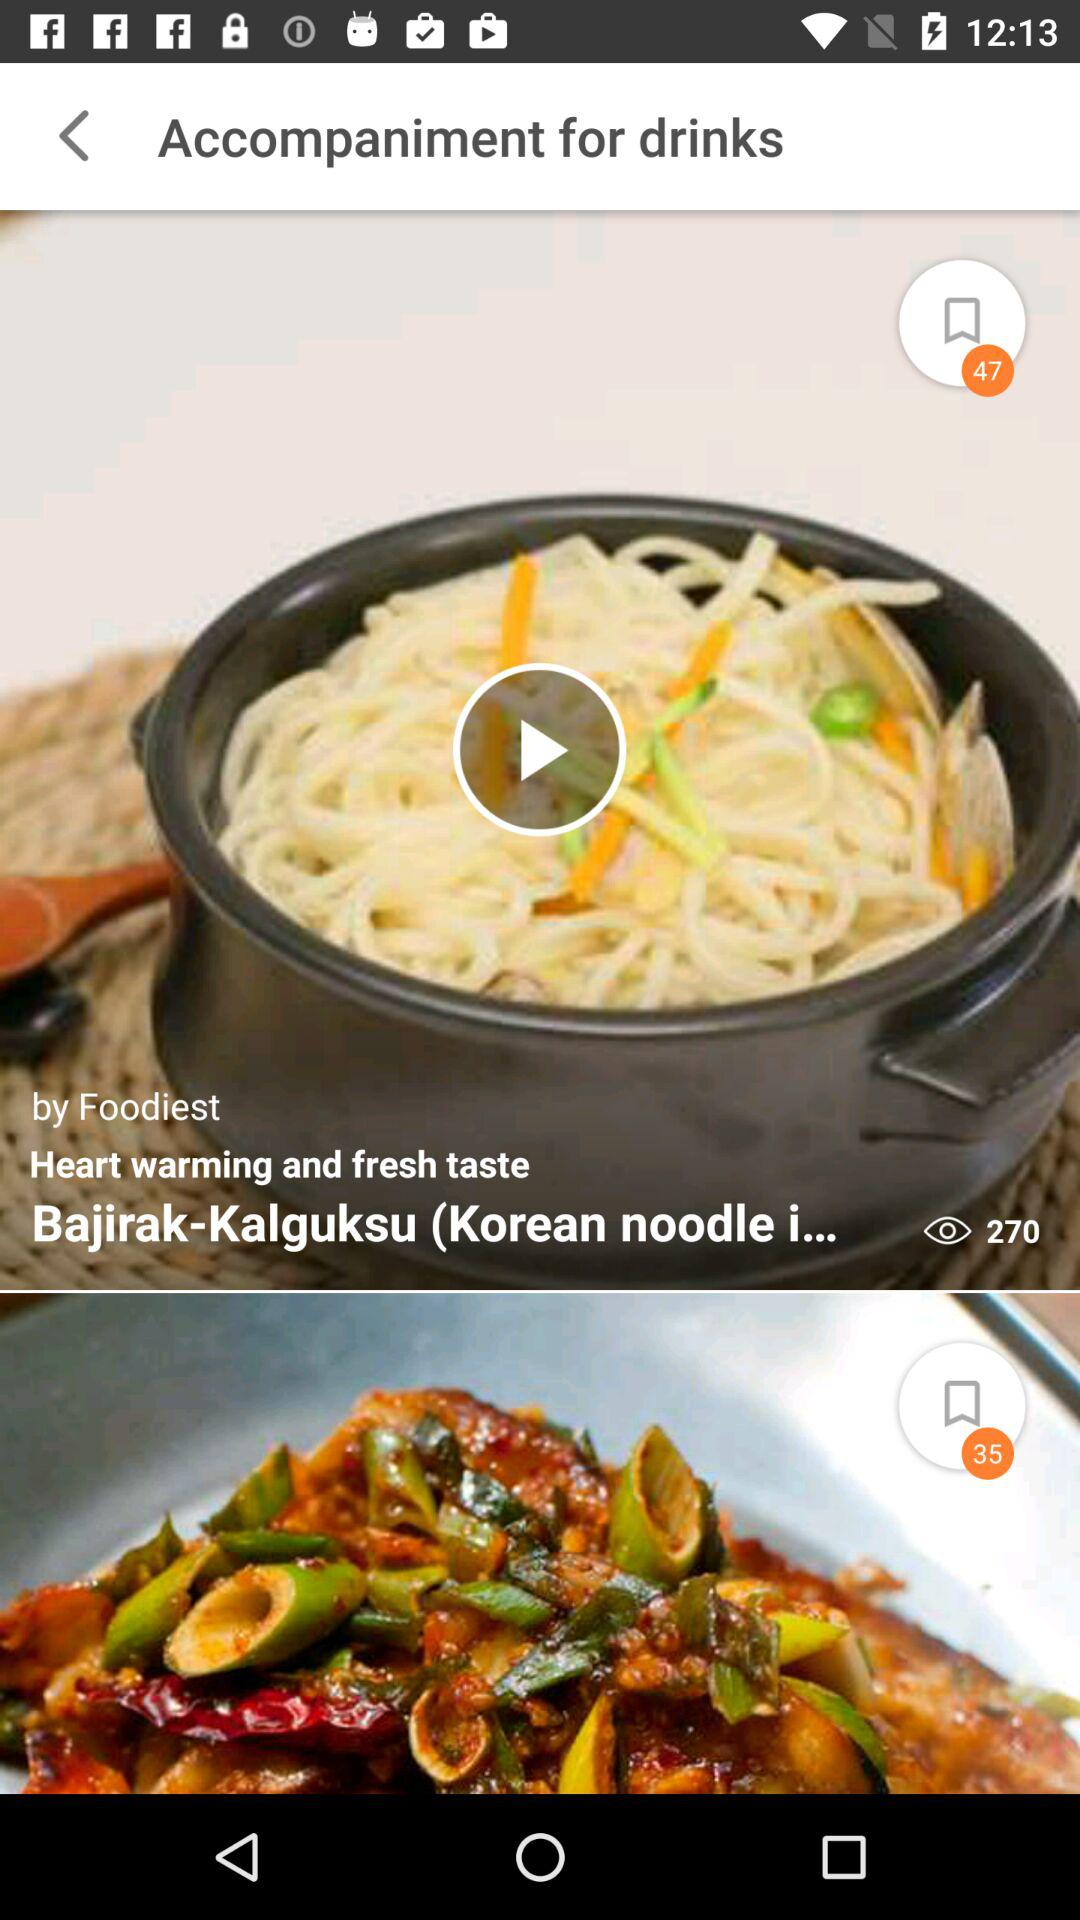How many views are there? There are 270 views. 